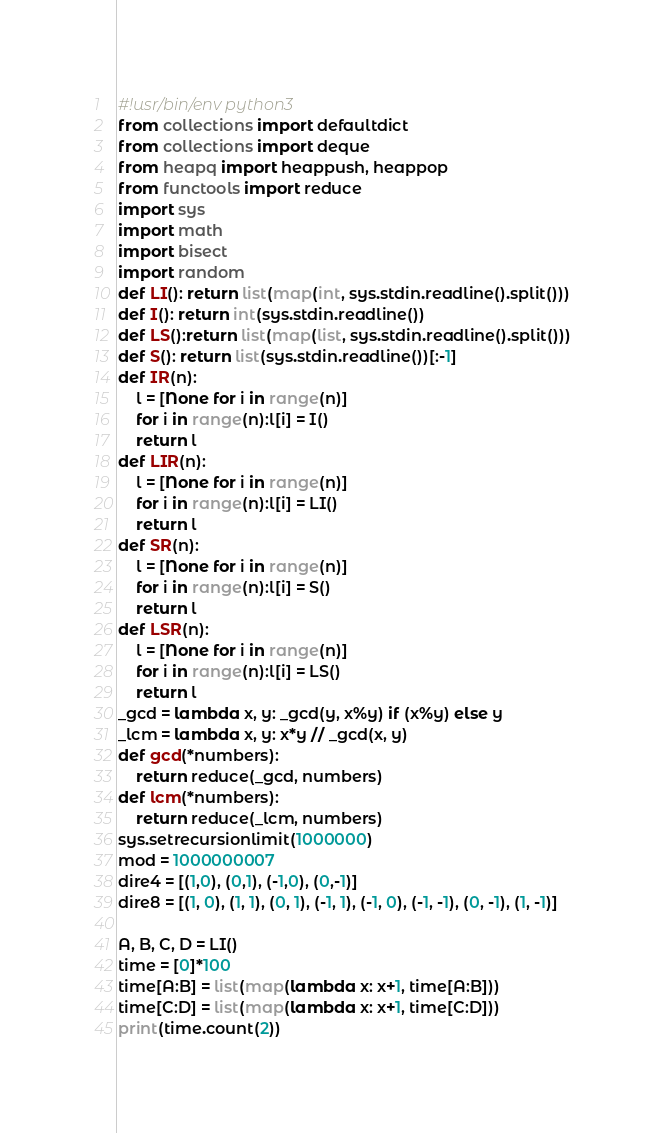Convert code to text. <code><loc_0><loc_0><loc_500><loc_500><_Python_>#!usr/bin/env python3
from collections import defaultdict
from collections import deque
from heapq import heappush, heappop
from functools import reduce
import sys
import math
import bisect
import random
def LI(): return list(map(int, sys.stdin.readline().split()))
def I(): return int(sys.stdin.readline())
def LS():return list(map(list, sys.stdin.readline().split()))
def S(): return list(sys.stdin.readline())[:-1]
def IR(n):
    l = [None for i in range(n)]
    for i in range(n):l[i] = I()
    return l
def LIR(n):
    l = [None for i in range(n)]
    for i in range(n):l[i] = LI()
    return l
def SR(n):
    l = [None for i in range(n)]
    for i in range(n):l[i] = S()
    return l
def LSR(n):
    l = [None for i in range(n)]
    for i in range(n):l[i] = LS()
    return l
_gcd = lambda x, y: _gcd(y, x%y) if (x%y) else y
_lcm = lambda x, y: x*y // _gcd(x, y)
def gcd(*numbers):
    return reduce(_gcd, numbers)
def lcm(*numbers):
    return reduce(_lcm, numbers)
sys.setrecursionlimit(1000000)
mod = 1000000007
dire4 = [(1,0), (0,1), (-1,0), (0,-1)]
dire8 = [(1, 0), (1, 1), (0, 1), (-1, 1), (-1, 0), (-1, -1), (0, -1), (1, -1)]

A, B, C, D = LI()
time = [0]*100
time[A:B] = list(map(lambda x: x+1, time[A:B]))
time[C:D] = list(map(lambda x: x+1, time[C:D]))
print(time.count(2))</code> 